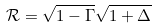<formula> <loc_0><loc_0><loc_500><loc_500>\mathcal { R } = \sqrt { 1 - \Gamma } \sqrt { 1 + \Delta }</formula> 